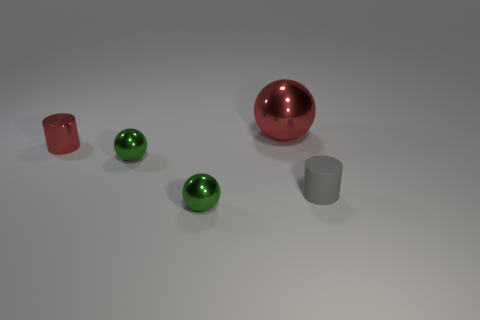Is the material of the red thing on the left side of the large red object the same as the red thing to the right of the red metallic cylinder?
Keep it short and to the point. Yes. What is the material of the large red ball?
Your answer should be very brief. Metal. How many other objects are the same color as the big metallic ball?
Provide a succinct answer. 1. Do the metal cylinder and the large sphere have the same color?
Your response must be concise. Yes. How many large yellow rubber blocks are there?
Your answer should be very brief. 0. The tiny cylinder that is to the right of the small green object in front of the tiny gray rubber cylinder is made of what material?
Offer a terse response. Rubber. What is the material of the gray cylinder that is the same size as the red metal cylinder?
Make the answer very short. Rubber. There is a cylinder that is in front of the metallic cylinder; does it have the same size as the tiny red shiny object?
Make the answer very short. Yes. There is a green shiny thing behind the tiny gray cylinder; is it the same shape as the rubber object?
Provide a short and direct response. No. How many objects are either tiny gray rubber things or tiny objects that are to the left of the big red metallic thing?
Keep it short and to the point. 4. 